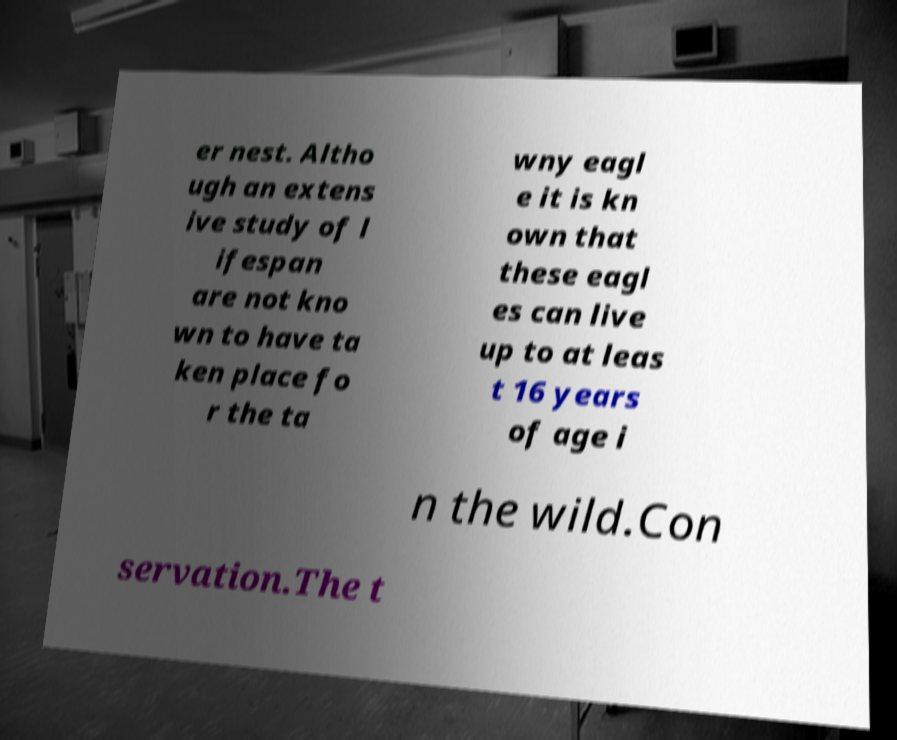Please identify and transcribe the text found in this image. er nest. Altho ugh an extens ive study of l ifespan are not kno wn to have ta ken place fo r the ta wny eagl e it is kn own that these eagl es can live up to at leas t 16 years of age i n the wild.Con servation.The t 